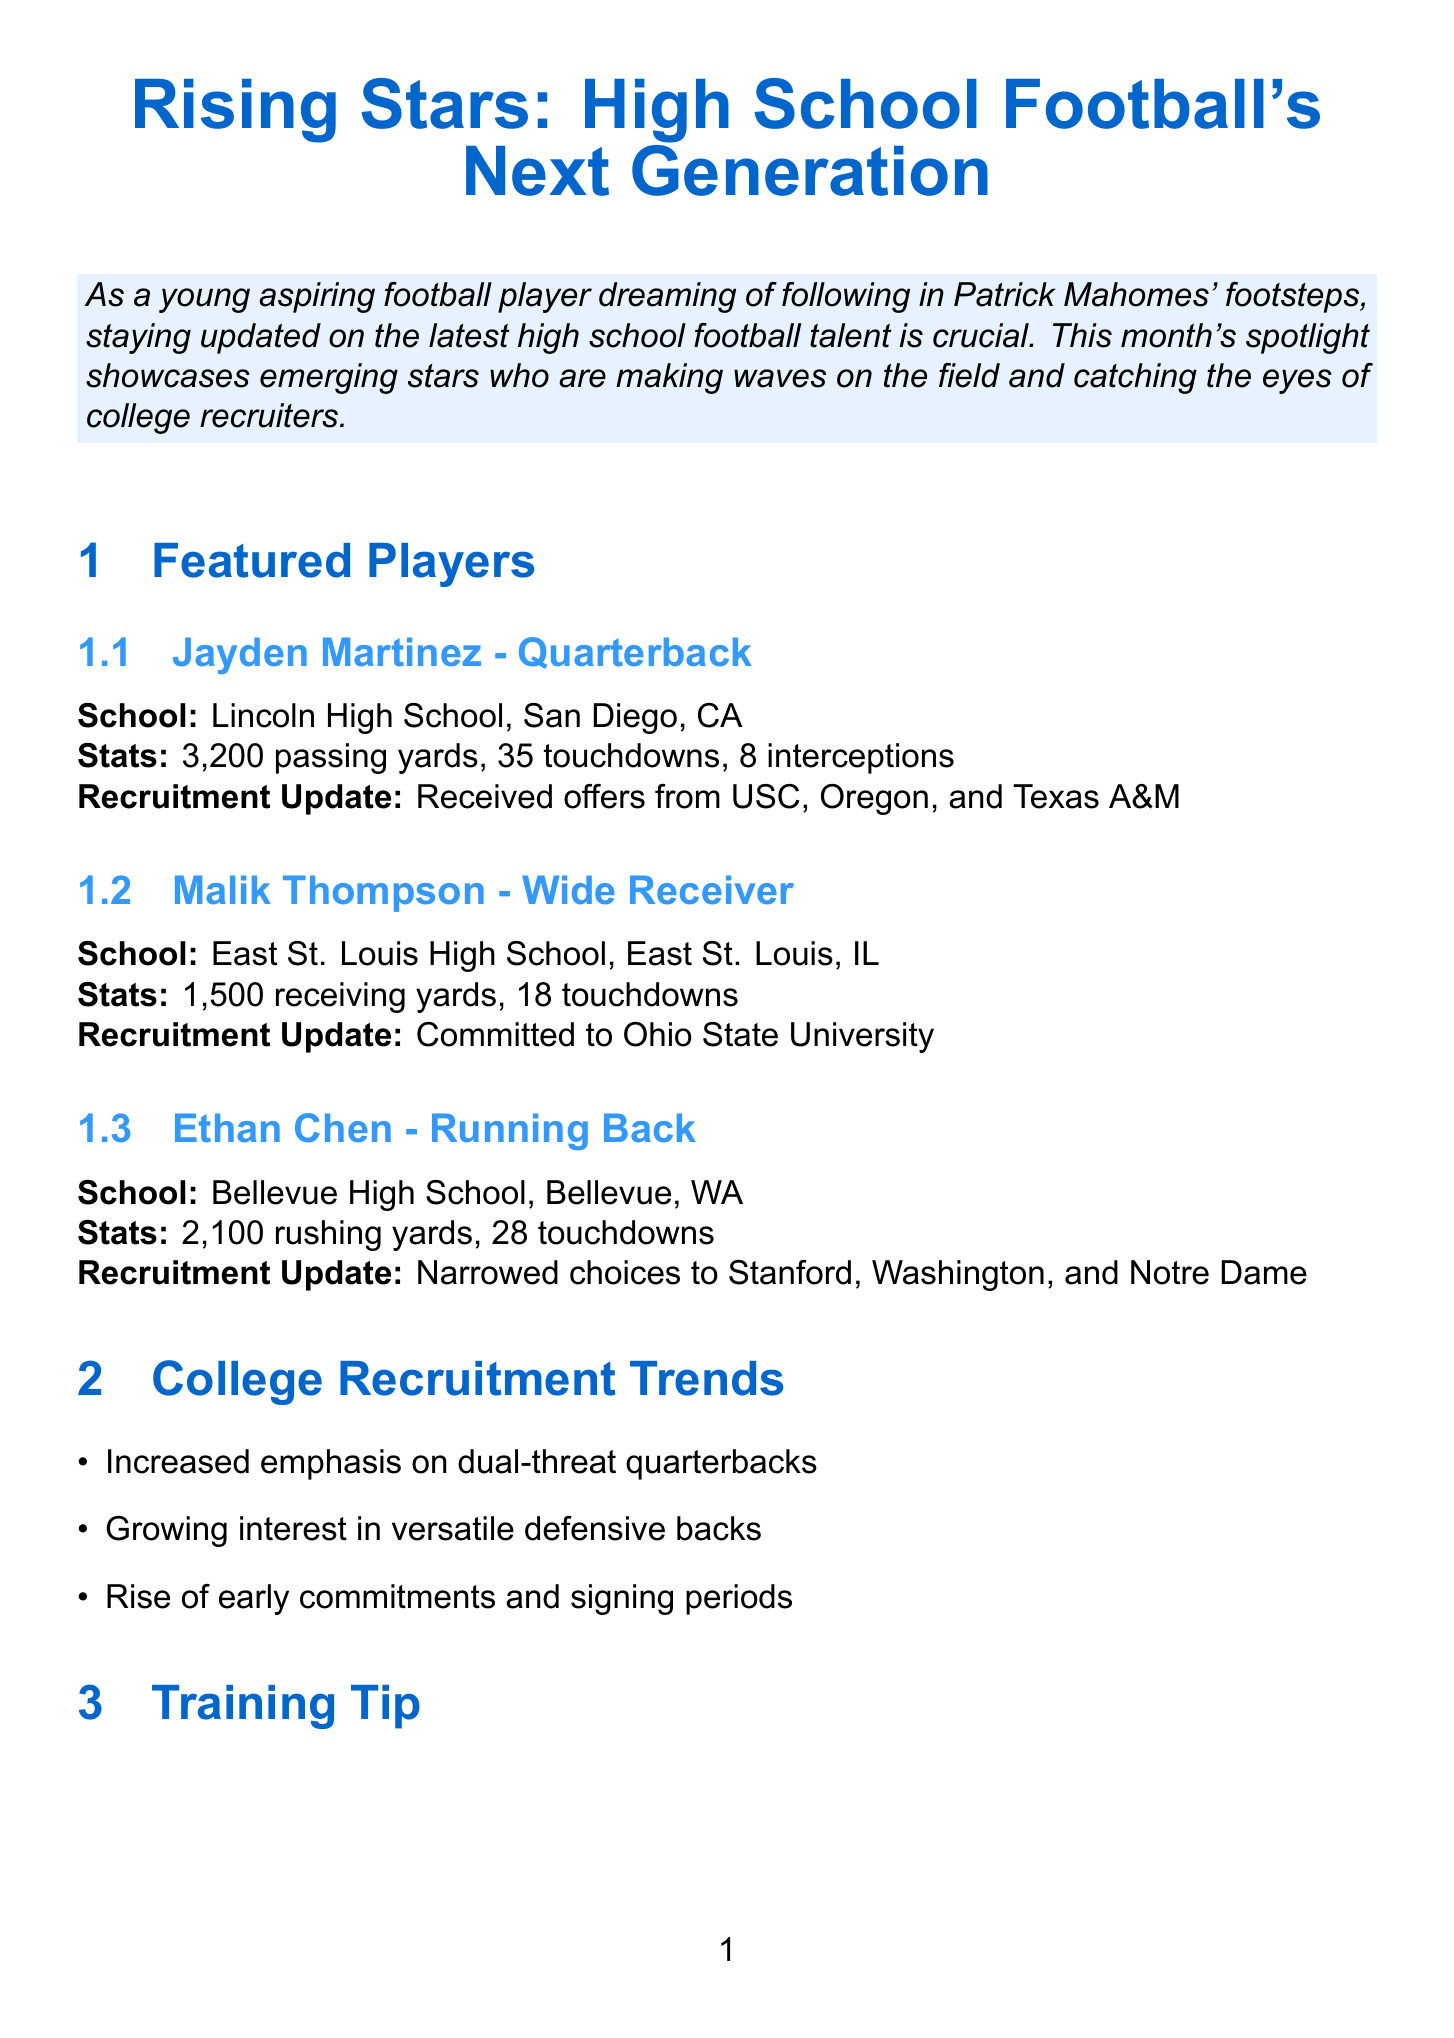what is the title of the newsletter? The title of the newsletter is mentioned at the top of the document.
Answer: Rising Stars: High School Football's Next Generation who is the featured wide receiver in this newsletter? The newsletter lists several featured players, including their positions and schools.
Answer: Malik Thompson how many passing yards did Jayden Martinez achieve? The newsletter provides specific statistics for each featured player, including passing yards.
Answer: 3,200 passing yards which school is Ethan Chen associated with? The newsletter states the school affiliation of each featured player.
Answer: Bellevue High School, Bellevue, WA what recruitment update does Malik Thompson have? The newsletter includes recruitment updates for each featured player.
Answer: Committed to Ohio State University which event is scheduled for July 15-17, 2023? The newsletter outlines upcoming events along with their dates and locations.
Answer: Elite 11 Quarterback Competition what is the training tip mentioned in this newsletter? The document provides a specific training tip related to improving skills, typical for such newsletters.
Answer: Improve your footwork like Patrick Mahomes: Practice ladder drills and cone exercises daily to enhance agility and quickness what quality does Coach Mike Norvell emphasize in players? The newsletter includes insights from a college coach regarding player qualities sought in recruitment.
Answer: Leadership, work ethic, and a passion for the game how many touchdowns did Ethan Chen score? The newsletter gives specific statistics for each player's performance.
Answer: 28 touchdowns 